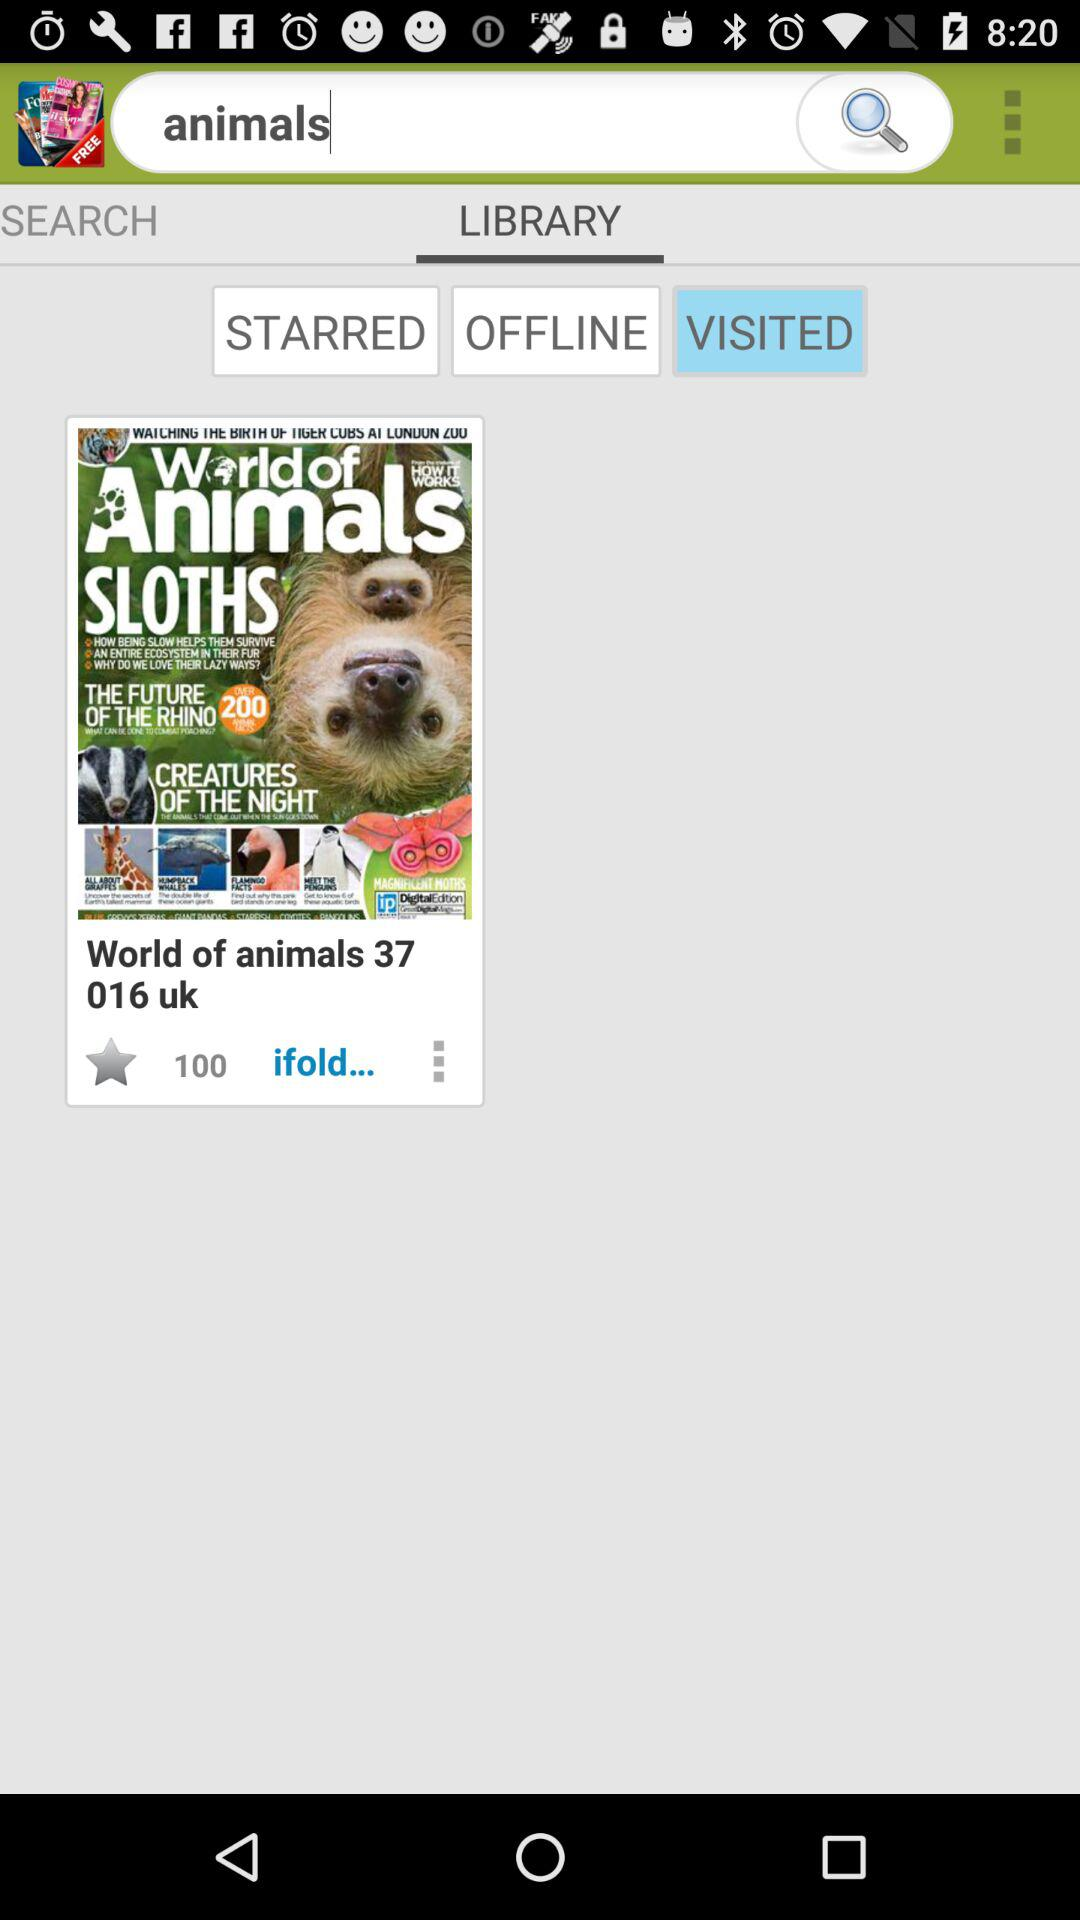What library option is selected? The selected library option is "VISITED". 